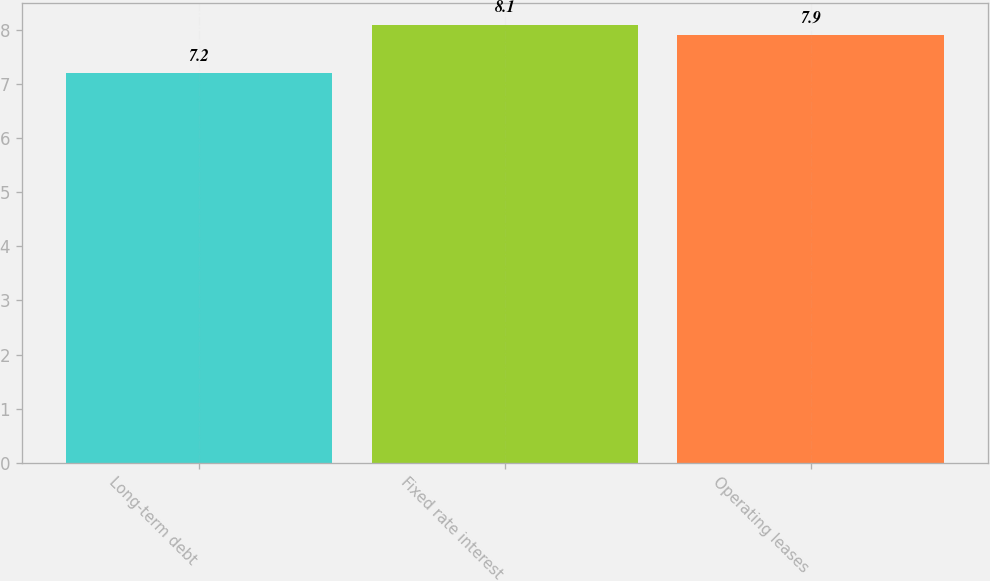Convert chart. <chart><loc_0><loc_0><loc_500><loc_500><bar_chart><fcel>Long-term debt<fcel>Fixed rate interest<fcel>Operating leases<nl><fcel>7.2<fcel>8.1<fcel>7.9<nl></chart> 